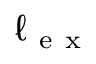Convert formula to latex. <formula><loc_0><loc_0><loc_500><loc_500>\ell _ { e x }</formula> 